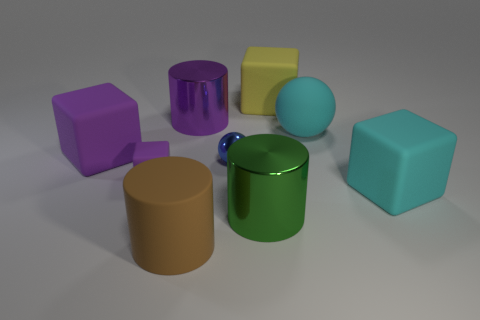Can you tell me the different colors visible in the objects? Certainly! The objects in the image display an array of colors including purple, cyan, yellow, teal, green, and a shade of brownish-orange. 